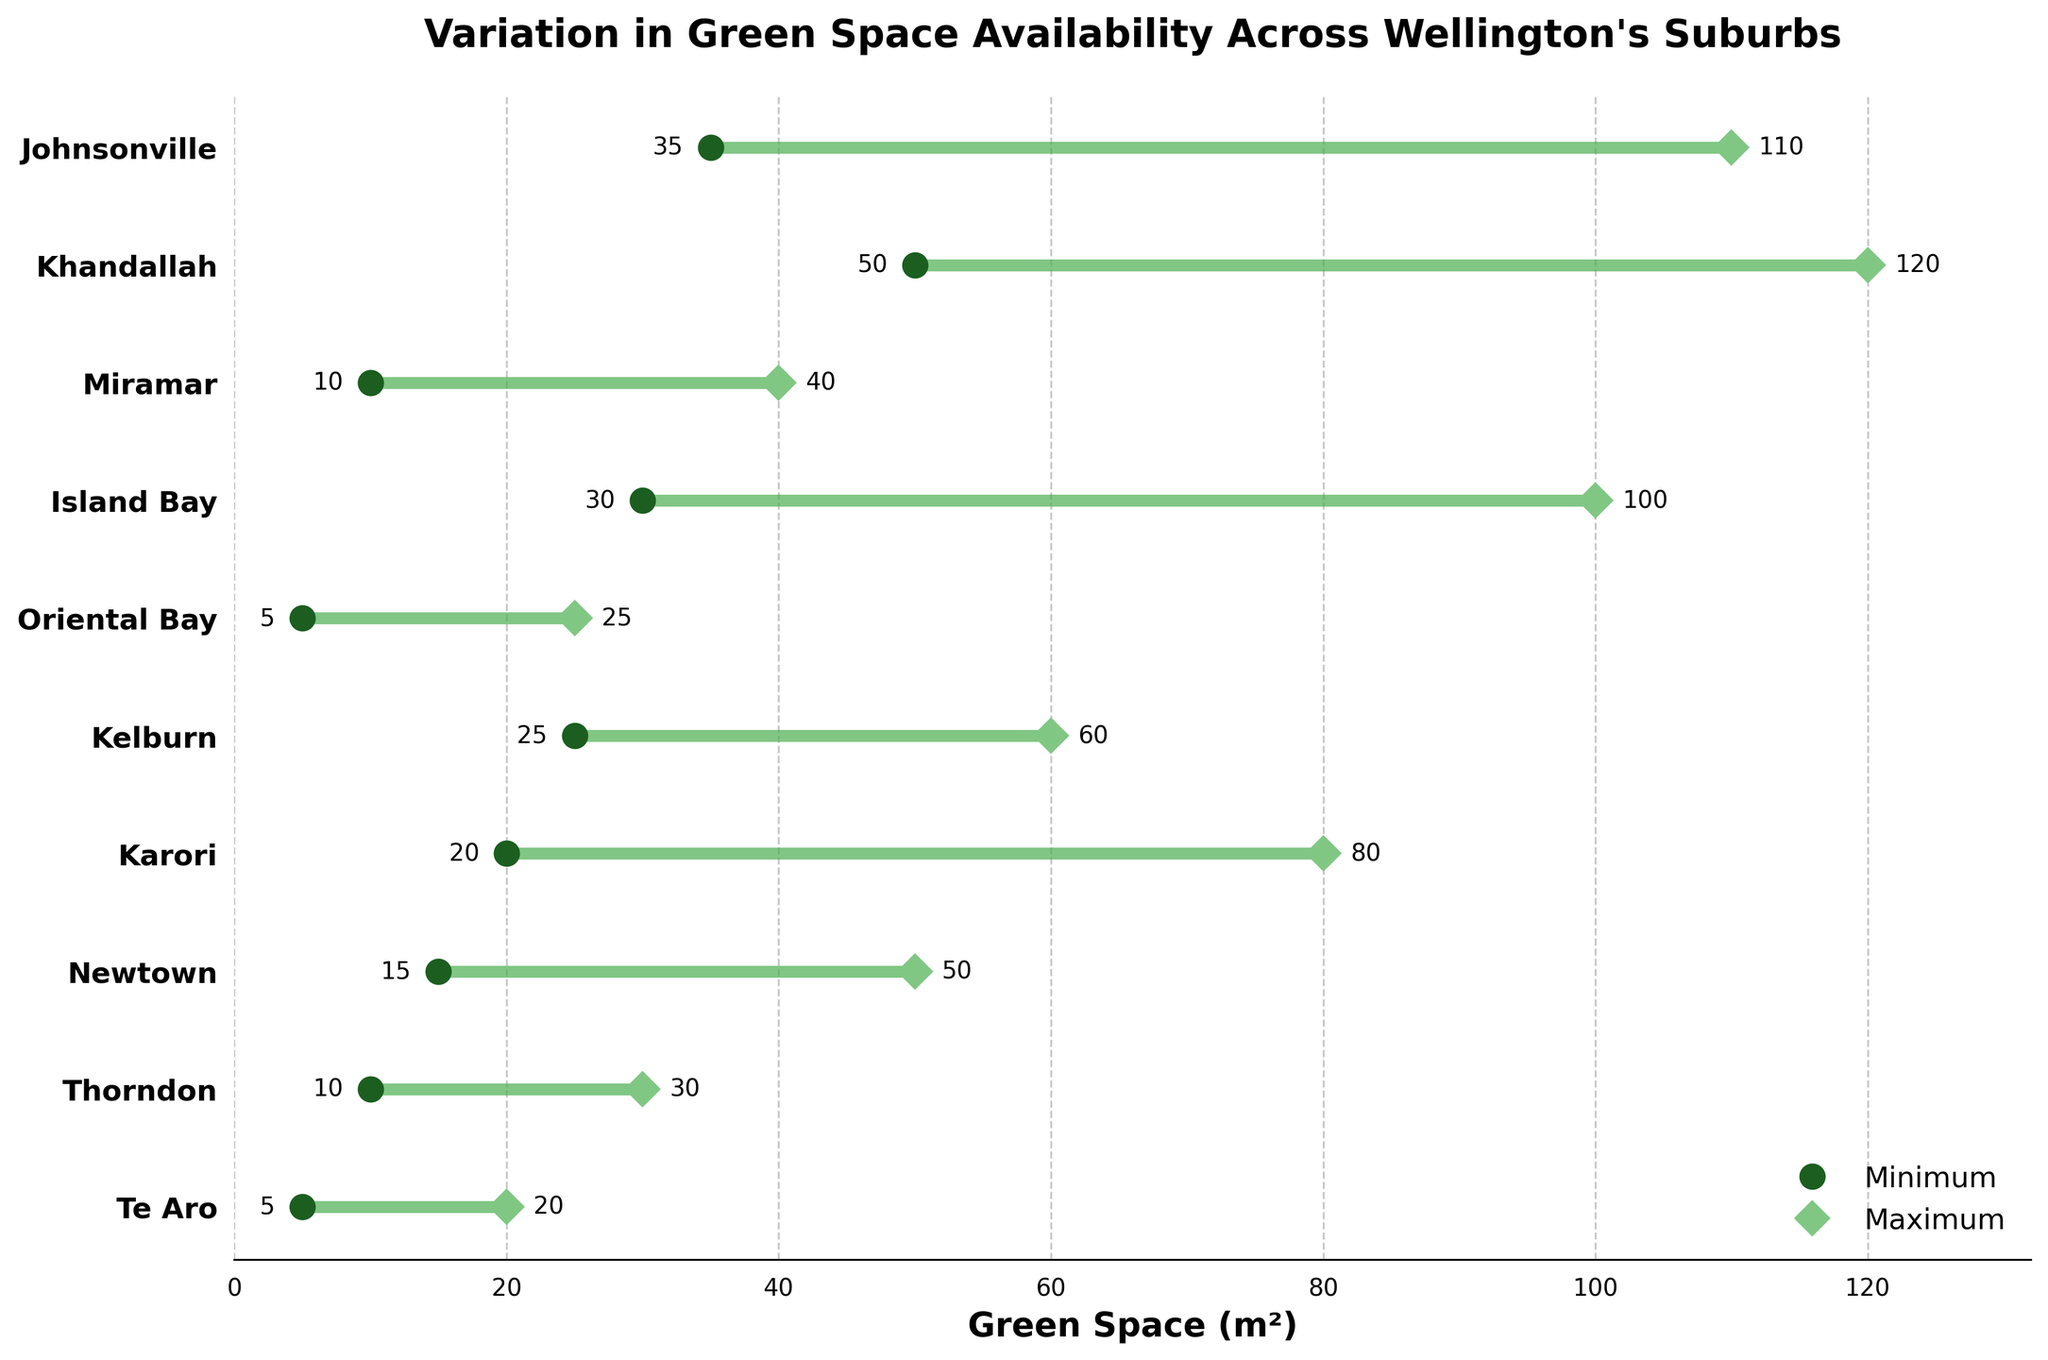What is the maximum green space available in Johnsonville? The figure shows that Johnsonville has a range for green space availability. The maximum green space is marked by a diamond symbol and is labeled on the plot.
Answer: 110 m² How many suburbs have a minimum green space of 10 m² or less? By looking at the plot, we identify the minimum green space values marked by circular symbols. Check each symbol to find which ones meet the criterion.
Answer: 3 (Te Aro, Thorndon, Miramar) Which suburb has the largest range of green space availability? To find the suburb with the largest range, calculate the difference between maximum and minimum green space for each suburb. The suburb with the largest difference is the answer.
Answer: Khandallah What is the minimum green space availability in Karori? The figure shows that Karori has a range for green space availability. The minimum green space is marked by a circular symbol and labeled on the plot.
Answer: 20 m² Which suburbs have a maximum green space availability greater than 80 m²? To find the suburbs with a maximum green space greater than 80 m², look at the diamond symbols that are labeled on the plot. Check each label to see if it is greater than 80 m².
Answer: Khandallah, Johnsonville What is the range of green space availability in Newtown? The range is the difference between the maximum and minimum green space availability for Newtown. These values are shown and labeled in the plot. Subtract the minimum from the maximum value.
Answer: 35 m² Between Island Bay and Miramar, which has a larger minimum green space availability? Compare the minimum green space values marked by circular symbols for both Island Bay and Miramar. The suburb with the larger value is the answer.
Answer: Island Bay Is there any suburb with both minimum and maximum green space values within the range of Te Aro's values? Check the range of green space values for Te Aro and compare them with other suburbs' ranges. Determine if any suburb’s both minimum and maximum values fall within Te Aro’s minimum and maximum range.
Answer: No What is the average of the maximum green space availabilities shown in the figure? Sum all maximum green space availabilities and divide by the number of suburbs. Values: 20, 30, 50, 80, 60, 25, 100, 40, 120, 110. Calculate (20 + 30 + 50 + 80 + 60 + 25 + 100 + 40 + 120 + 110) / 10.
Answer: 63.5 m² How does the maximum green space availability in Oriental Bay compare to that in Kelburn? Compare the maximum green space values marked by diamond symbols for both Oriental Bay and Kelburn. Check if the value in one is greater or smaller than the other.
Answer: Smaller 